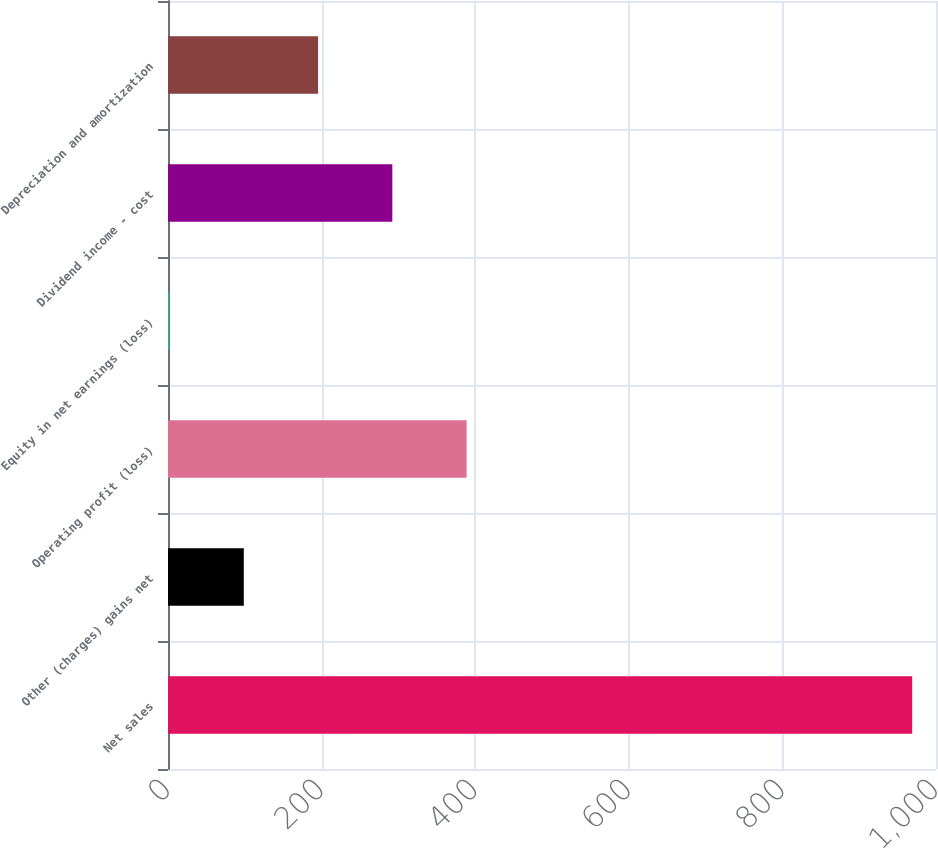<chart> <loc_0><loc_0><loc_500><loc_500><bar_chart><fcel>Net sales<fcel>Other (charges) gains net<fcel>Operating profit (loss)<fcel>Equity in net earnings (loss)<fcel>Dividend income - cost<fcel>Depreciation and amortization<nl><fcel>969<fcel>98.7<fcel>388.8<fcel>2<fcel>292.1<fcel>195.4<nl></chart> 